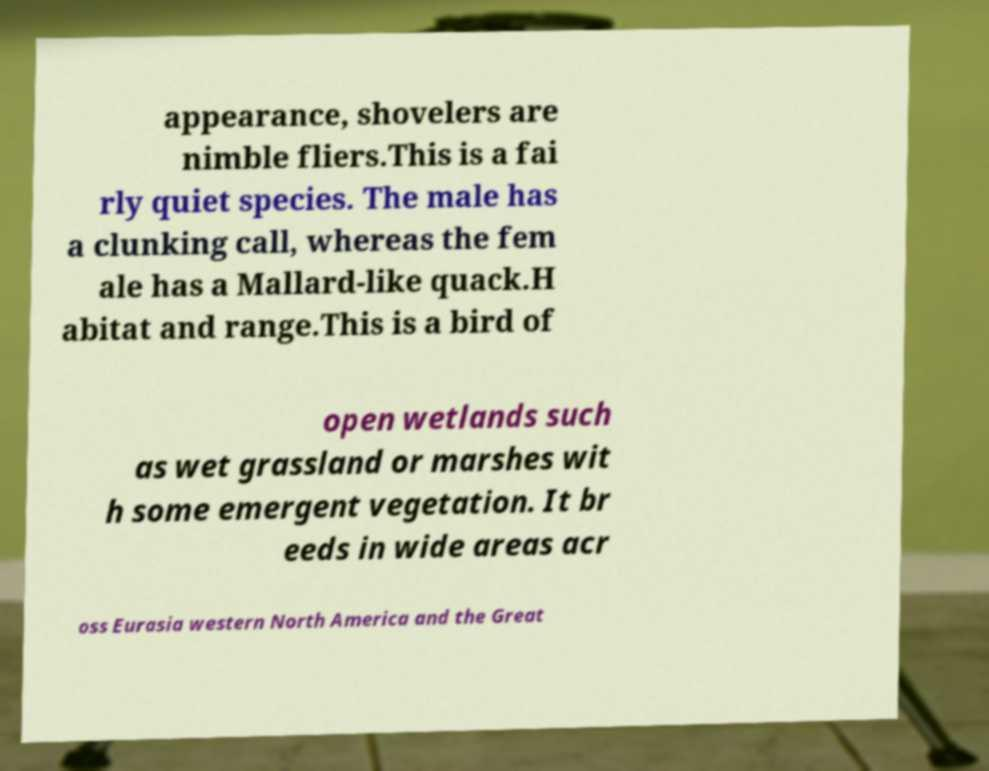What messages or text are displayed in this image? I need them in a readable, typed format. appearance, shovelers are nimble fliers.This is a fai rly quiet species. The male has a clunking call, whereas the fem ale has a Mallard-like quack.H abitat and range.This is a bird of open wetlands such as wet grassland or marshes wit h some emergent vegetation. It br eeds in wide areas acr oss Eurasia western North America and the Great 